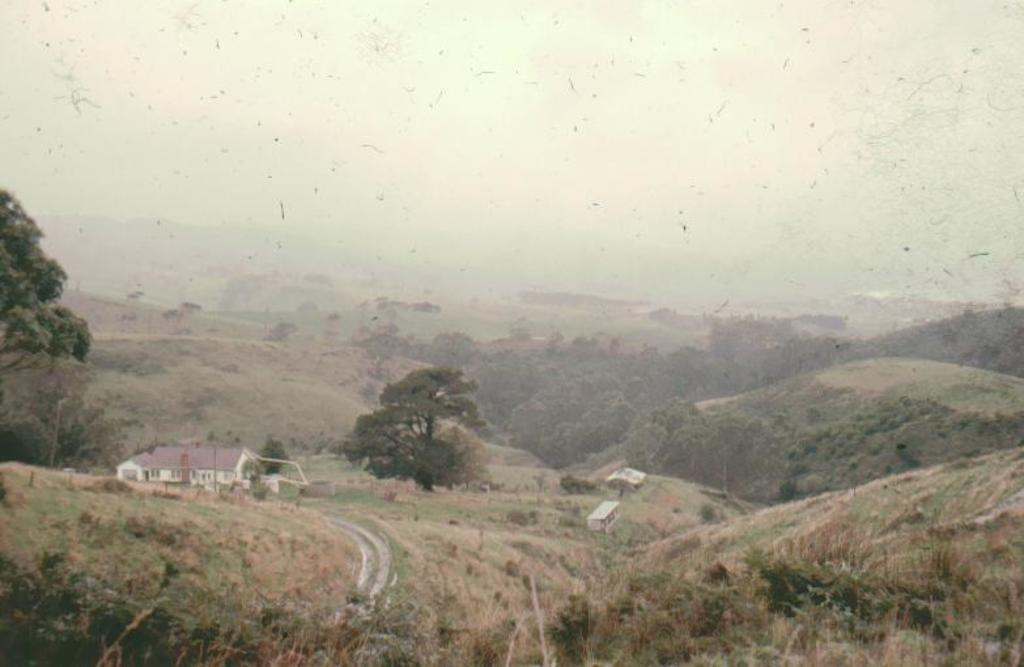What type of vegetation is in the front of the image? There are plants in the front of the image. What can be seen in the background of the image? There are trees, houses, and mountains in the background of the image. What is the condition of the sky in the image? The sky is cloudy in the image. What type of clock is visible in the image? There is no clock present in the image. 